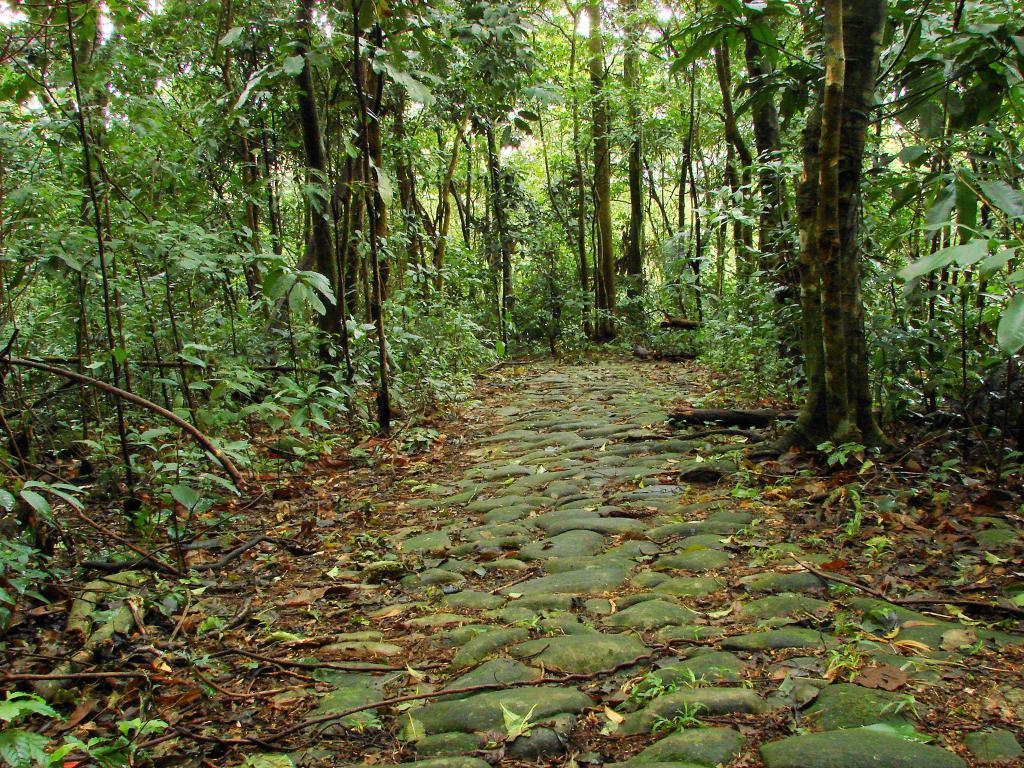In one or two sentences, can you explain what this image depicts? In this picture we can see a stone pathway with trees and plants on either side. 